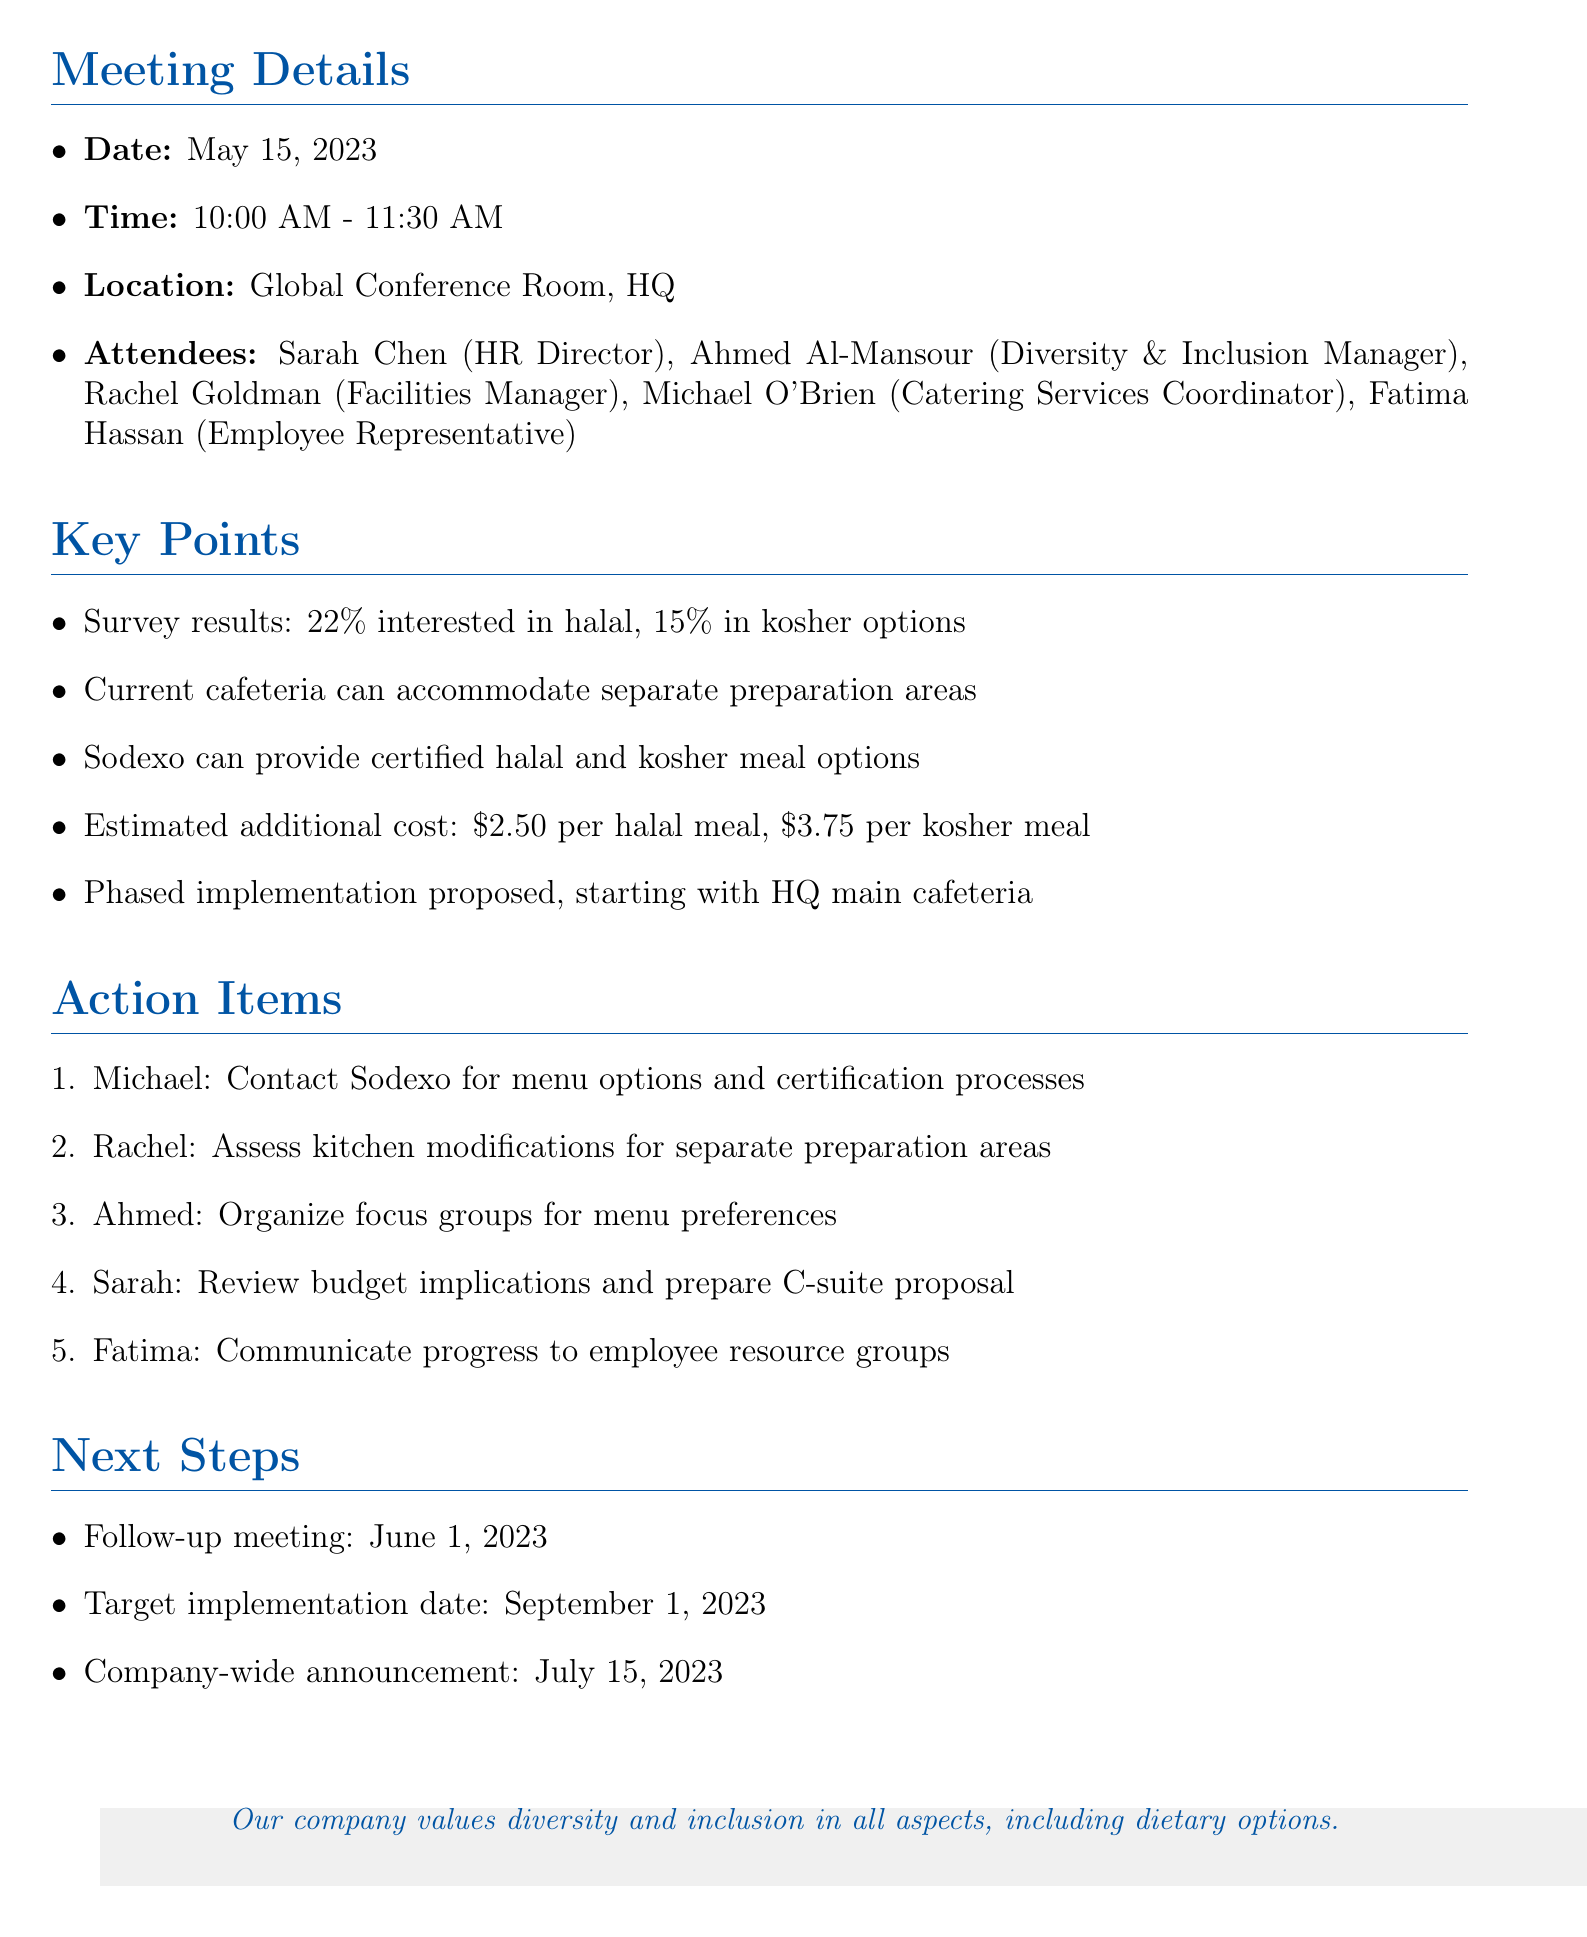What is the date of the meeting? The date of the meeting is listed in the meeting details section.
Answer: May 15, 2023 Who is the Catering Services Coordinator? The name of the Catering Services Coordinator is mentioned among the attendees.
Answer: Michael O'Brien What percentage of employees are interested in halal options? The survey results provide specific percentages of interest among employees in different food options.
Answer: 22% What is the estimated additional cost for kosher meals? The estimated costs for halal and kosher meals are provided in the key points section.
Answer: $3.75 What action item is assigned to Ahmed? The action items list specifies tasks for each attendee, including Ahmed.
Answer: Organize focus groups for menu preferences When is the follow-up meeting scheduled? The next steps section includes the date for the follow-up meeting.
Answer: June 1, 2023 What is the target implementation date for the new food options? Information regarding the target implementation date is provided in the next steps section.
Answer: September 1, 2023 Which catering partner can provide halal and kosher meals? The key points section mentions the current catering partner's capability regarding halal and kosher meals.
Answer: Sodexo What is the location of the meeting? The location is specified in the meeting details section.
Answer: Global Conference Room, HQ 